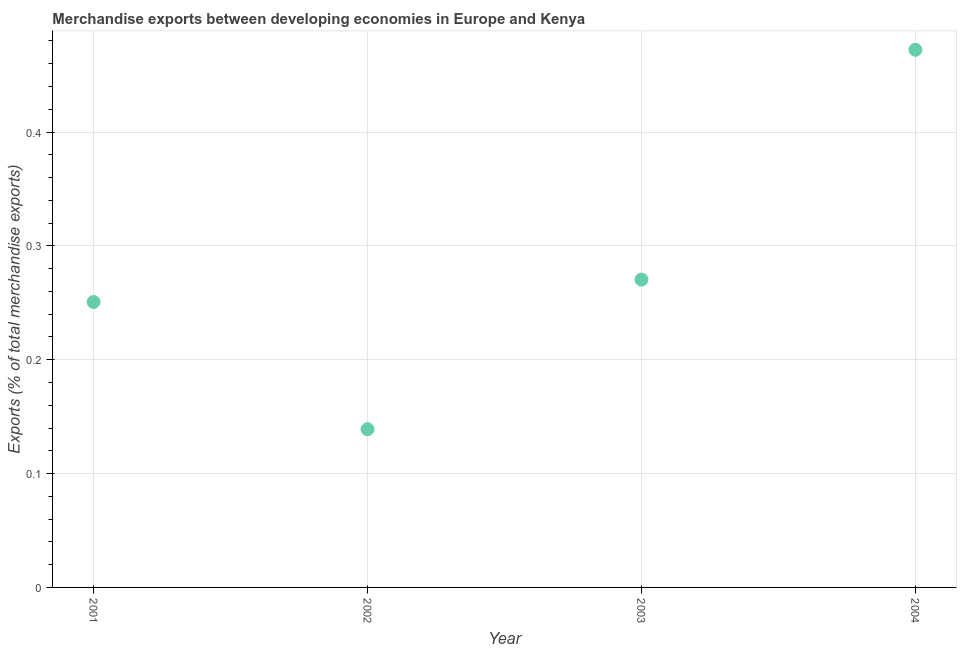What is the merchandise exports in 2004?
Your response must be concise. 0.47. Across all years, what is the maximum merchandise exports?
Keep it short and to the point. 0.47. Across all years, what is the minimum merchandise exports?
Ensure brevity in your answer.  0.14. In which year was the merchandise exports maximum?
Your answer should be very brief. 2004. In which year was the merchandise exports minimum?
Offer a very short reply. 2002. What is the sum of the merchandise exports?
Your answer should be very brief. 1.13. What is the difference between the merchandise exports in 2002 and 2004?
Provide a succinct answer. -0.33. What is the average merchandise exports per year?
Your response must be concise. 0.28. What is the median merchandise exports?
Your response must be concise. 0.26. What is the ratio of the merchandise exports in 2001 to that in 2002?
Offer a terse response. 1.8. Is the merchandise exports in 2003 less than that in 2004?
Offer a very short reply. Yes. What is the difference between the highest and the second highest merchandise exports?
Provide a succinct answer. 0.2. Is the sum of the merchandise exports in 2001 and 2003 greater than the maximum merchandise exports across all years?
Provide a succinct answer. Yes. What is the difference between the highest and the lowest merchandise exports?
Your response must be concise. 0.33. In how many years, is the merchandise exports greater than the average merchandise exports taken over all years?
Offer a very short reply. 1. Does the merchandise exports monotonically increase over the years?
Provide a succinct answer. No. How many years are there in the graph?
Your answer should be very brief. 4. What is the difference between two consecutive major ticks on the Y-axis?
Your answer should be very brief. 0.1. What is the title of the graph?
Provide a short and direct response. Merchandise exports between developing economies in Europe and Kenya. What is the label or title of the Y-axis?
Offer a very short reply. Exports (% of total merchandise exports). What is the Exports (% of total merchandise exports) in 2001?
Your answer should be compact. 0.25. What is the Exports (% of total merchandise exports) in 2002?
Your answer should be compact. 0.14. What is the Exports (% of total merchandise exports) in 2003?
Give a very brief answer. 0.27. What is the Exports (% of total merchandise exports) in 2004?
Your answer should be very brief. 0.47. What is the difference between the Exports (% of total merchandise exports) in 2001 and 2002?
Provide a short and direct response. 0.11. What is the difference between the Exports (% of total merchandise exports) in 2001 and 2003?
Ensure brevity in your answer.  -0.02. What is the difference between the Exports (% of total merchandise exports) in 2001 and 2004?
Provide a short and direct response. -0.22. What is the difference between the Exports (% of total merchandise exports) in 2002 and 2003?
Give a very brief answer. -0.13. What is the difference between the Exports (% of total merchandise exports) in 2002 and 2004?
Your answer should be compact. -0.33. What is the difference between the Exports (% of total merchandise exports) in 2003 and 2004?
Keep it short and to the point. -0.2. What is the ratio of the Exports (% of total merchandise exports) in 2001 to that in 2002?
Keep it short and to the point. 1.8. What is the ratio of the Exports (% of total merchandise exports) in 2001 to that in 2003?
Your response must be concise. 0.93. What is the ratio of the Exports (% of total merchandise exports) in 2001 to that in 2004?
Your answer should be compact. 0.53. What is the ratio of the Exports (% of total merchandise exports) in 2002 to that in 2003?
Your answer should be very brief. 0.51. What is the ratio of the Exports (% of total merchandise exports) in 2002 to that in 2004?
Offer a very short reply. 0.29. What is the ratio of the Exports (% of total merchandise exports) in 2003 to that in 2004?
Keep it short and to the point. 0.57. 